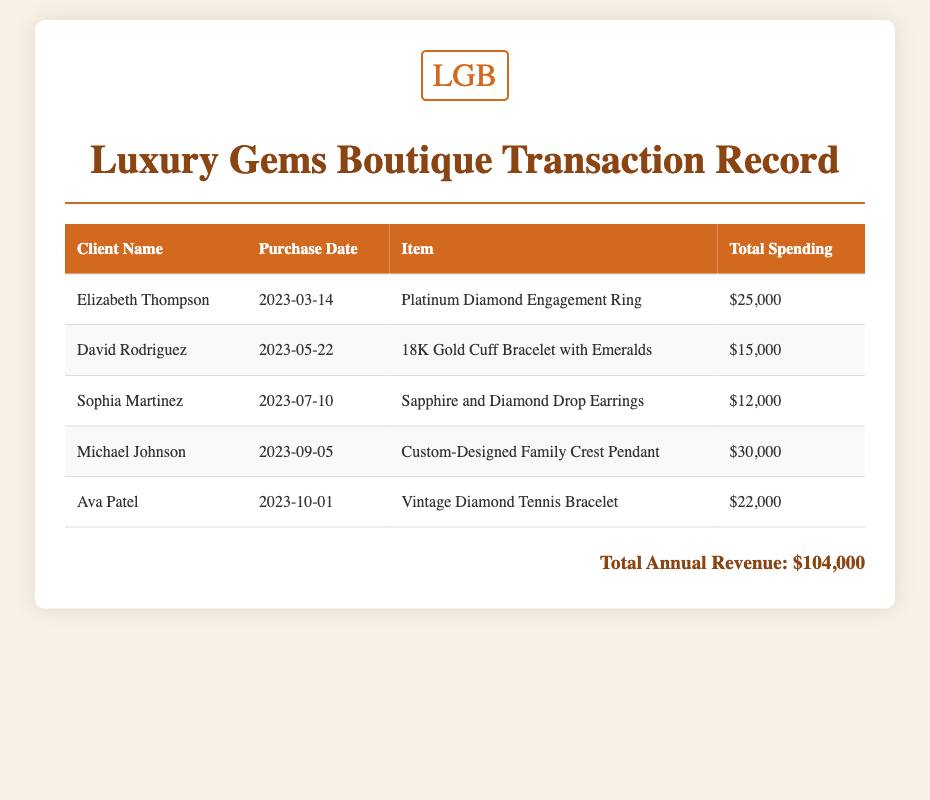What is the total annual revenue? The total annual revenue is displayed at the bottom of the document as the sum of all transactions, which is $104,000.
Answer: $104,000 Who purchased the Platinum Diamond Engagement Ring? The document lists the client associated with this purchase as Elizabeth Thompson.
Answer: Elizabeth Thompson When did David Rodriguez make his purchase? The purchase date for David Rodriguez is indicated next to his name in the document as 2023-05-22.
Answer: 2023-05-22 What item did Sophia Martinez buy? The item purchased by Sophia Martinez, as stated in the document, is the Sapphire and Diamond Drop Earrings.
Answer: Sapphire and Diamond Drop Earrings Which client spent the most amount in a single transaction? By comparing the total spending amounts, Michael Johnson's Custom-Designed Family Crest Pendant purchase at $30,000 is the highest.
Answer: Michael Johnson How many clients are listed in the transaction record? The document contains a total of five different clients who made purchases over the past year.
Answer: 5 What is the purchase date for Ava Patel? The document specifies Ava Patel's purchase date as 2023-10-01, listed next to her name.
Answer: 2023-10-01 What is the total spending for the Vintage Diamond Tennis Bracelet? The spending for the Vintage Diamond Tennis Bracelet, purchased by Ava Patel, is noted in the document as $22,000.
Answer: $22,000 What type of document is this? This document is a transaction record listing purchases made by clients at Luxury Gems Boutique.
Answer: Transaction Record 